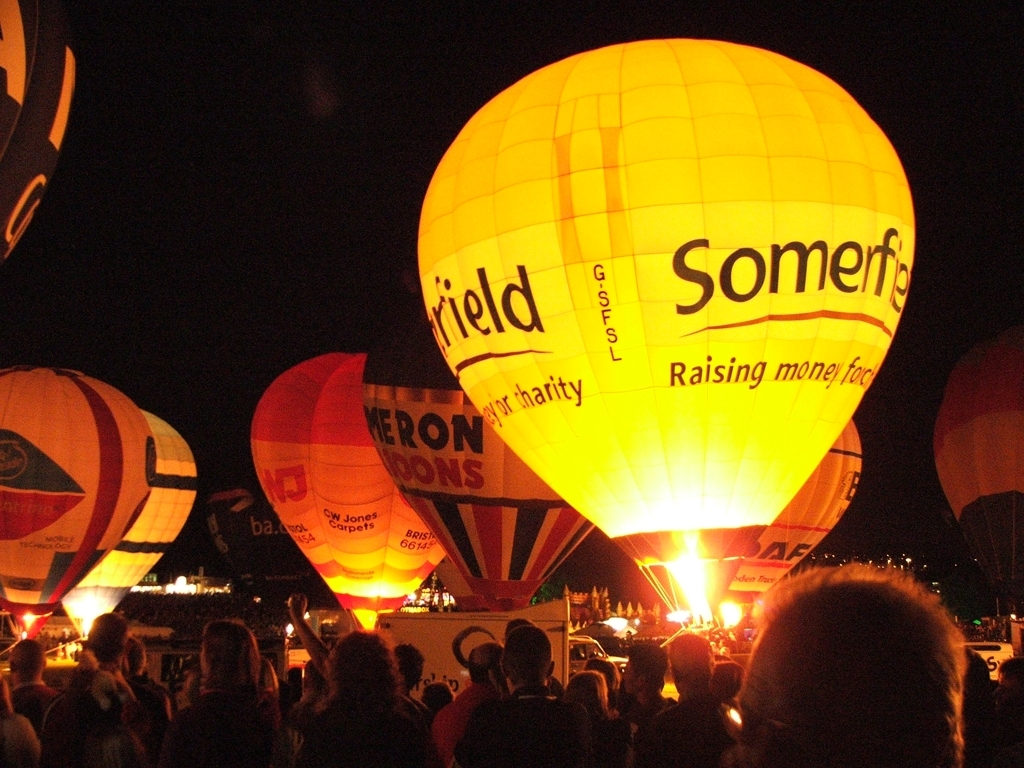What's the occasion that these hot air balloons are gathered for? These hot air balloons are likely gathered for a festival or a public event, which often includes night glows where balloons are illuminated after dark to create a spectacular visual display. The text on some balloons indicates that at least one of them is part of a charity fundraising effort. 